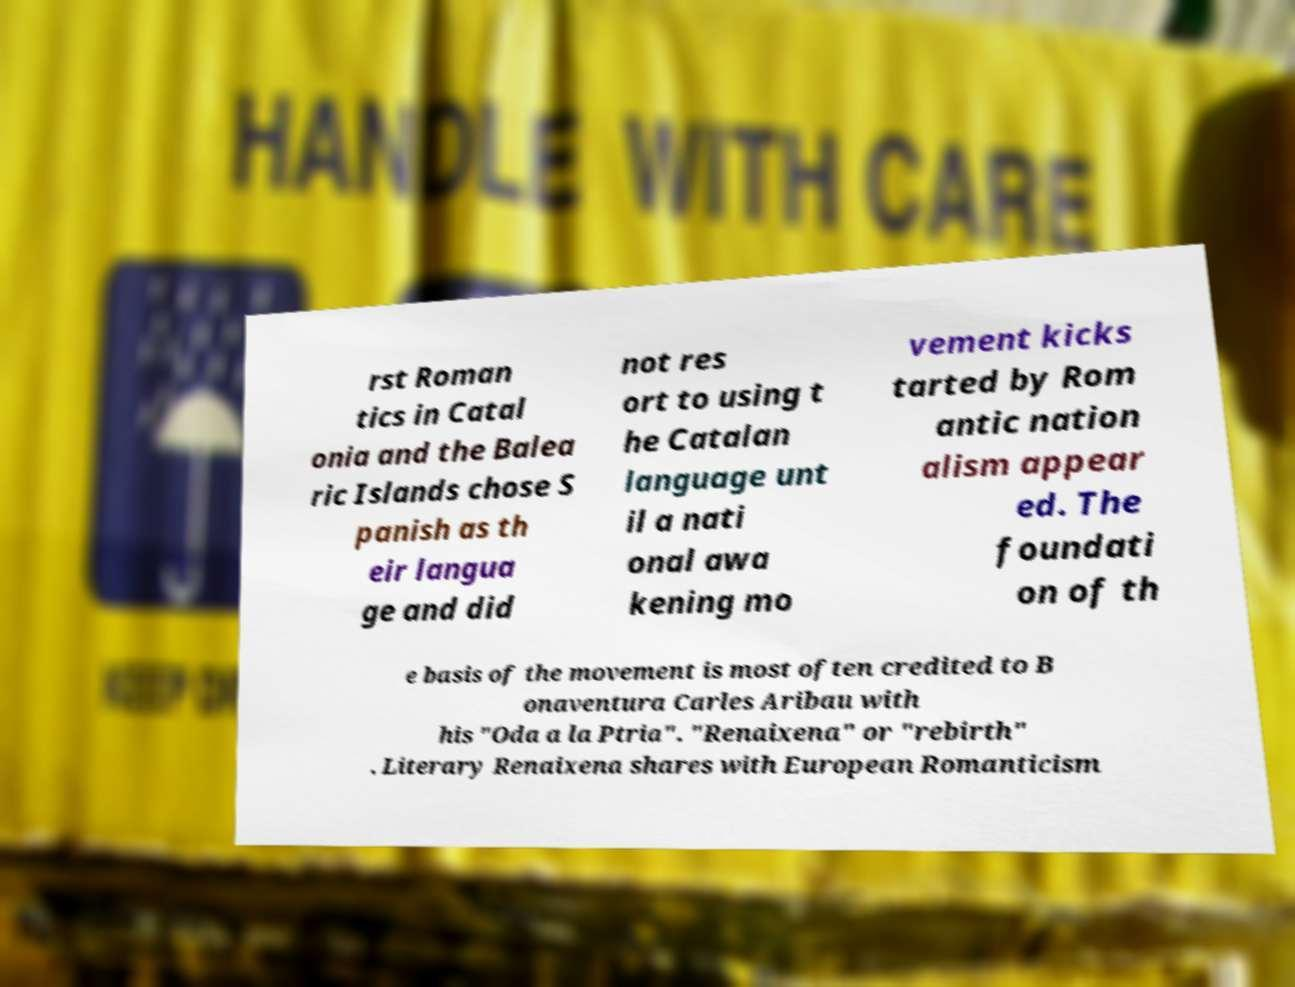Can you accurately transcribe the text from the provided image for me? rst Roman tics in Catal onia and the Balea ric Islands chose S panish as th eir langua ge and did not res ort to using t he Catalan language unt il a nati onal awa kening mo vement kicks tarted by Rom antic nation alism appear ed. The foundati on of th e basis of the movement is most often credited to B onaventura Carles Aribau with his "Oda a la Ptria". "Renaixena" or "rebirth" . Literary Renaixena shares with European Romanticism 